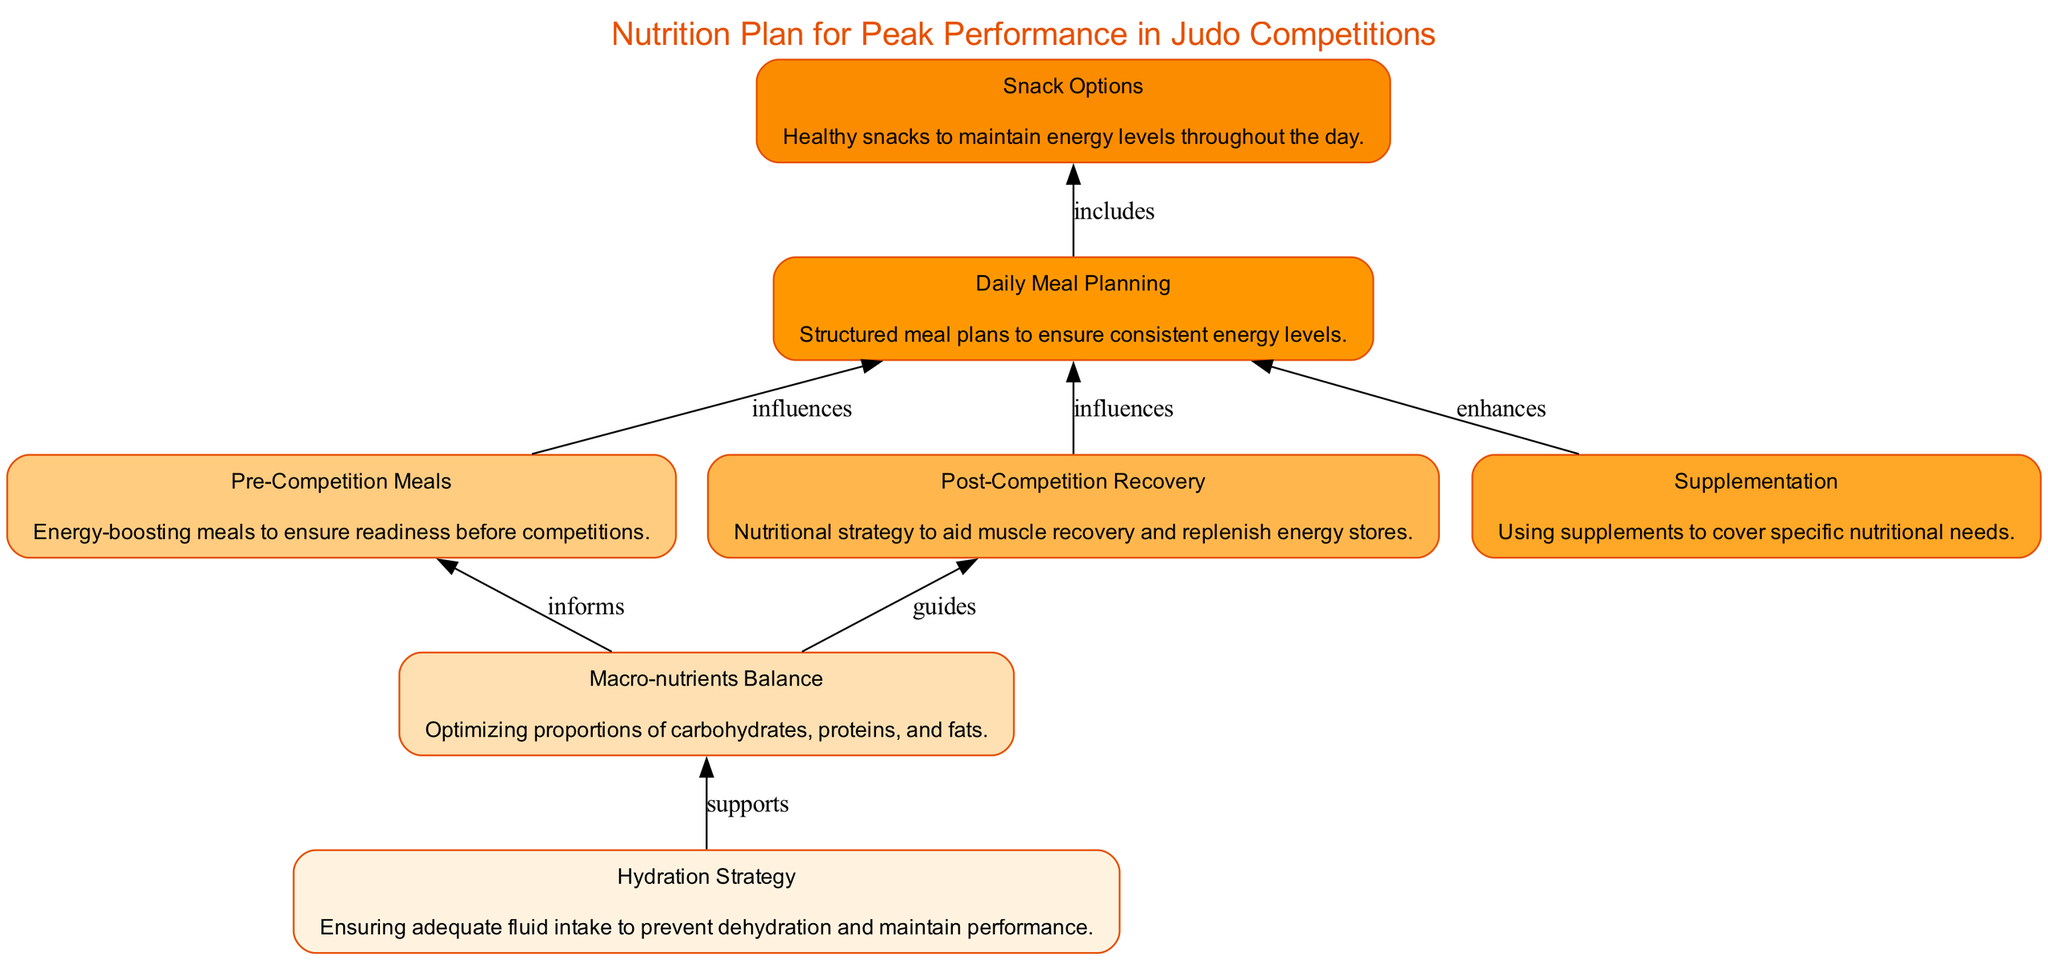What is the first element in the diagram? The first element in the diagram, appearing at the bottom, is "Hydration Strategy." It is the starting point of the flow, indicating the importance of hydration as the foundation of the nutrition plan.
Answer: Hydration Strategy How many main elements are in the nutrition plan? There are a total of seven main elements in the nutrition plan, as represented by the seven distinct nodes in the diagram. Each element contributes to the overall strategy for peak performance.
Answer: Seven Which element directly influences Daily Meal Planning? Daily Meal Planning is influenced by both Pre-Competition Meals and Post-Competition Recovery, as indicated by the arrows connecting these elements to Daily Meal Planning.
Answer: Pre-Competition Meals and Post-Competition Recovery What supports the Macro-nutrients Balance? The Hydro Strategy supports the Macro-nutrients Balance, as there is a direct edge from Hydration Strategy to Macro-nutrients Balance in the diagram. This indicates that adequate hydration impacts nutrient balance.
Answer: Hydration Strategy What is included in the Snack Options? The Snack Options list includes healthy snacks for different times of day: yogurt, nuts, fruit, cheese sticks, vegetable sticks, and hummus, as detailed in the description of Snack Options.
Answer: Yogurt, nuts, fruit, cheese sticks, vegetable sticks, and hummus Which element enhances Daily Meal Planning? The element that enhances Daily Meal Planning is Supplementation, as shown by the directed connection from Supplementation to Daily Meal Planning in the flow. This suggests that supplementation contributes to the effectiveness of daily meals.
Answer: Supplementation What percentage of daily intake should be proteins? Proteins should make up 20-30% of daily intake, according to the details provided for the Macro-nutrients Balance element in the diagram.
Answer: 20-30% Which component is listed under Post-Competition Recovery? The components under Post-Competition Recovery include simple carbs, proteins, and hydration, showing the nutritional strategy aimed at recovery after competition.
Answer: Simple Carbs, Proteins, and Hydration 